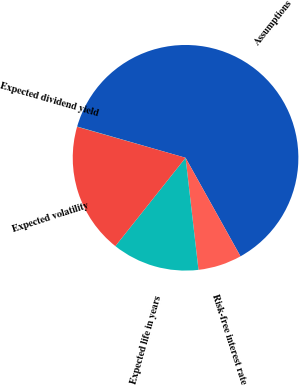Convert chart. <chart><loc_0><loc_0><loc_500><loc_500><pie_chart><fcel>Assumptions<fcel>Risk-free interest rate<fcel>Expected life in years<fcel>Expected volatility<fcel>Expected dividend yield<nl><fcel>62.44%<fcel>6.27%<fcel>12.51%<fcel>18.75%<fcel>0.03%<nl></chart> 